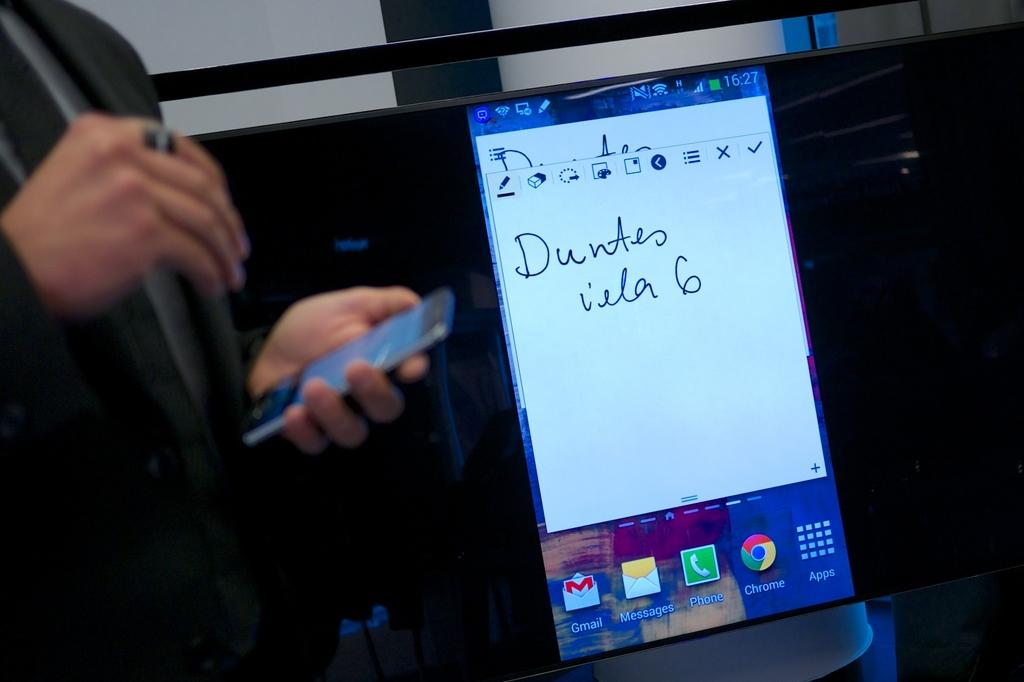What is the man in the image doing? The man is standing in the image. What object is the man holding in his hand? The man is holding a mobile phone in his hand. Is there another mobile phone in the image? Yes, there is a mobile phone screen on the table. What type of spark can be seen coming from the man's hand in the image? There is no spark visible in the image. What is the man using to hit the mobile phone screen on the table? The man is not using a hammer or any other object to hit the mobile phone screen in the image. 